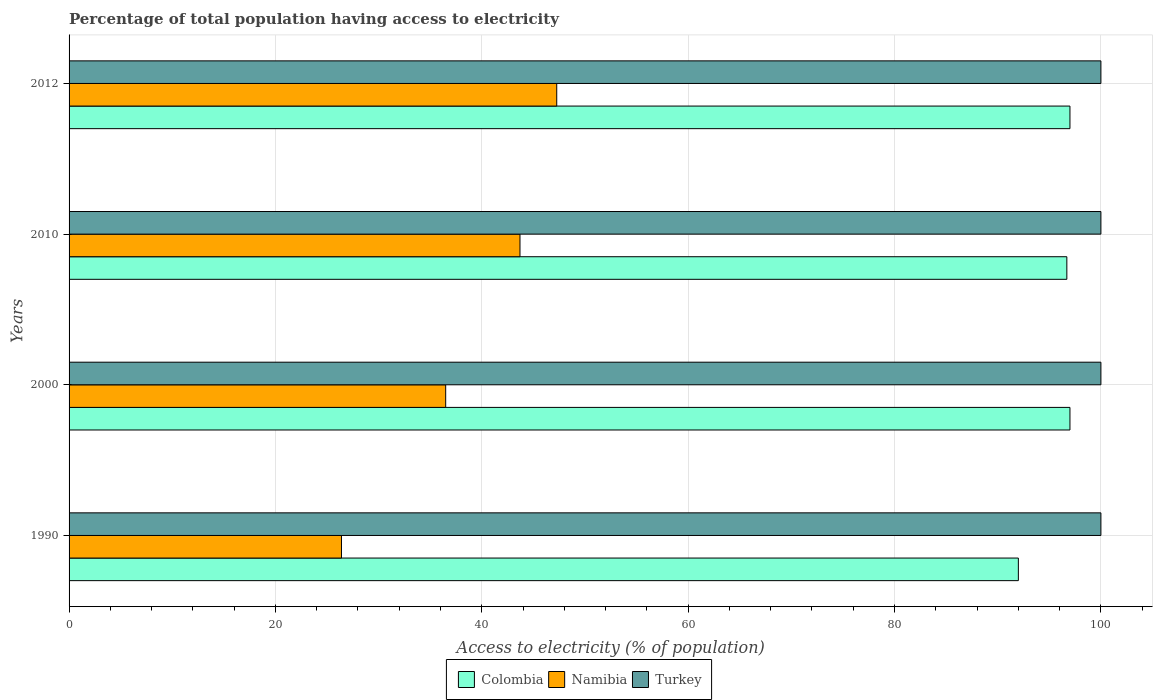How many groups of bars are there?
Keep it short and to the point. 4. Are the number of bars per tick equal to the number of legend labels?
Give a very brief answer. Yes. What is the percentage of population that have access to electricity in Colombia in 1990?
Give a very brief answer. 92. Across all years, what is the maximum percentage of population that have access to electricity in Namibia?
Provide a succinct answer. 47.26. Across all years, what is the minimum percentage of population that have access to electricity in Namibia?
Keep it short and to the point. 26.4. In which year was the percentage of population that have access to electricity in Colombia maximum?
Make the answer very short. 2000. What is the total percentage of population that have access to electricity in Namibia in the graph?
Ensure brevity in your answer.  153.86. What is the average percentage of population that have access to electricity in Namibia per year?
Ensure brevity in your answer.  38.47. What is the ratio of the percentage of population that have access to electricity in Colombia in 1990 to that in 2010?
Make the answer very short. 0.95. What is the difference between the highest and the second highest percentage of population that have access to electricity in Namibia?
Your answer should be compact. 3.56. Is the sum of the percentage of population that have access to electricity in Namibia in 1990 and 2010 greater than the maximum percentage of population that have access to electricity in Colombia across all years?
Your answer should be very brief. No. What does the 3rd bar from the top in 2000 represents?
Offer a very short reply. Colombia. What does the 1st bar from the bottom in 2000 represents?
Offer a very short reply. Colombia. Is it the case that in every year, the sum of the percentage of population that have access to electricity in Turkey and percentage of population that have access to electricity in Namibia is greater than the percentage of population that have access to electricity in Colombia?
Your response must be concise. Yes. How many bars are there?
Ensure brevity in your answer.  12. Are all the bars in the graph horizontal?
Make the answer very short. Yes. What is the difference between two consecutive major ticks on the X-axis?
Your response must be concise. 20. Are the values on the major ticks of X-axis written in scientific E-notation?
Your response must be concise. No. Does the graph contain any zero values?
Offer a very short reply. No. Does the graph contain grids?
Offer a very short reply. Yes. Where does the legend appear in the graph?
Provide a short and direct response. Bottom center. How are the legend labels stacked?
Keep it short and to the point. Horizontal. What is the title of the graph?
Your response must be concise. Percentage of total population having access to electricity. What is the label or title of the X-axis?
Offer a terse response. Access to electricity (% of population). What is the label or title of the Y-axis?
Offer a terse response. Years. What is the Access to electricity (% of population) of Colombia in 1990?
Offer a very short reply. 92. What is the Access to electricity (% of population) of Namibia in 1990?
Make the answer very short. 26.4. What is the Access to electricity (% of population) in Turkey in 1990?
Your answer should be very brief. 100. What is the Access to electricity (% of population) in Colombia in 2000?
Your response must be concise. 97. What is the Access to electricity (% of population) in Namibia in 2000?
Your answer should be very brief. 36.5. What is the Access to electricity (% of population) of Colombia in 2010?
Provide a short and direct response. 96.7. What is the Access to electricity (% of population) of Namibia in 2010?
Offer a terse response. 43.7. What is the Access to electricity (% of population) in Turkey in 2010?
Your answer should be compact. 100. What is the Access to electricity (% of population) in Colombia in 2012?
Your response must be concise. 97. What is the Access to electricity (% of population) in Namibia in 2012?
Keep it short and to the point. 47.26. Across all years, what is the maximum Access to electricity (% of population) of Colombia?
Offer a very short reply. 97. Across all years, what is the maximum Access to electricity (% of population) in Namibia?
Give a very brief answer. 47.26. Across all years, what is the minimum Access to electricity (% of population) in Colombia?
Give a very brief answer. 92. Across all years, what is the minimum Access to electricity (% of population) of Namibia?
Keep it short and to the point. 26.4. Across all years, what is the minimum Access to electricity (% of population) of Turkey?
Your response must be concise. 100. What is the total Access to electricity (% of population) of Colombia in the graph?
Keep it short and to the point. 382.7. What is the total Access to electricity (% of population) of Namibia in the graph?
Provide a succinct answer. 153.86. What is the total Access to electricity (% of population) in Turkey in the graph?
Provide a short and direct response. 400. What is the difference between the Access to electricity (% of population) in Colombia in 1990 and that in 2000?
Your answer should be compact. -5. What is the difference between the Access to electricity (% of population) in Namibia in 1990 and that in 2000?
Make the answer very short. -10.1. What is the difference between the Access to electricity (% of population) in Colombia in 1990 and that in 2010?
Give a very brief answer. -4.7. What is the difference between the Access to electricity (% of population) in Namibia in 1990 and that in 2010?
Your response must be concise. -17.3. What is the difference between the Access to electricity (% of population) in Namibia in 1990 and that in 2012?
Keep it short and to the point. -20.86. What is the difference between the Access to electricity (% of population) of Colombia in 2000 and that in 2010?
Offer a terse response. 0.3. What is the difference between the Access to electricity (% of population) of Namibia in 2000 and that in 2010?
Ensure brevity in your answer.  -7.2. What is the difference between the Access to electricity (% of population) in Turkey in 2000 and that in 2010?
Ensure brevity in your answer.  0. What is the difference between the Access to electricity (% of population) of Namibia in 2000 and that in 2012?
Give a very brief answer. -10.76. What is the difference between the Access to electricity (% of population) in Turkey in 2000 and that in 2012?
Provide a short and direct response. 0. What is the difference between the Access to electricity (% of population) in Colombia in 2010 and that in 2012?
Offer a very short reply. -0.3. What is the difference between the Access to electricity (% of population) in Namibia in 2010 and that in 2012?
Offer a terse response. -3.56. What is the difference between the Access to electricity (% of population) of Colombia in 1990 and the Access to electricity (% of population) of Namibia in 2000?
Your response must be concise. 55.5. What is the difference between the Access to electricity (% of population) in Colombia in 1990 and the Access to electricity (% of population) in Turkey in 2000?
Your answer should be compact. -8. What is the difference between the Access to electricity (% of population) of Namibia in 1990 and the Access to electricity (% of population) of Turkey in 2000?
Your answer should be very brief. -73.6. What is the difference between the Access to electricity (% of population) in Colombia in 1990 and the Access to electricity (% of population) in Namibia in 2010?
Your answer should be very brief. 48.3. What is the difference between the Access to electricity (% of population) of Colombia in 1990 and the Access to electricity (% of population) of Turkey in 2010?
Offer a very short reply. -8. What is the difference between the Access to electricity (% of population) in Namibia in 1990 and the Access to electricity (% of population) in Turkey in 2010?
Make the answer very short. -73.6. What is the difference between the Access to electricity (% of population) in Colombia in 1990 and the Access to electricity (% of population) in Namibia in 2012?
Ensure brevity in your answer.  44.74. What is the difference between the Access to electricity (% of population) in Colombia in 1990 and the Access to electricity (% of population) in Turkey in 2012?
Make the answer very short. -8. What is the difference between the Access to electricity (% of population) of Namibia in 1990 and the Access to electricity (% of population) of Turkey in 2012?
Offer a very short reply. -73.6. What is the difference between the Access to electricity (% of population) of Colombia in 2000 and the Access to electricity (% of population) of Namibia in 2010?
Make the answer very short. 53.3. What is the difference between the Access to electricity (% of population) of Colombia in 2000 and the Access to electricity (% of population) of Turkey in 2010?
Your response must be concise. -3. What is the difference between the Access to electricity (% of population) in Namibia in 2000 and the Access to electricity (% of population) in Turkey in 2010?
Offer a very short reply. -63.5. What is the difference between the Access to electricity (% of population) of Colombia in 2000 and the Access to electricity (% of population) of Namibia in 2012?
Your response must be concise. 49.74. What is the difference between the Access to electricity (% of population) of Namibia in 2000 and the Access to electricity (% of population) of Turkey in 2012?
Give a very brief answer. -63.5. What is the difference between the Access to electricity (% of population) in Colombia in 2010 and the Access to electricity (% of population) in Namibia in 2012?
Provide a succinct answer. 49.44. What is the difference between the Access to electricity (% of population) in Namibia in 2010 and the Access to electricity (% of population) in Turkey in 2012?
Provide a succinct answer. -56.3. What is the average Access to electricity (% of population) of Colombia per year?
Your response must be concise. 95.67. What is the average Access to electricity (% of population) in Namibia per year?
Ensure brevity in your answer.  38.47. What is the average Access to electricity (% of population) of Turkey per year?
Give a very brief answer. 100. In the year 1990, what is the difference between the Access to electricity (% of population) of Colombia and Access to electricity (% of population) of Namibia?
Make the answer very short. 65.6. In the year 1990, what is the difference between the Access to electricity (% of population) in Namibia and Access to electricity (% of population) in Turkey?
Your answer should be very brief. -73.6. In the year 2000, what is the difference between the Access to electricity (% of population) of Colombia and Access to electricity (% of population) of Namibia?
Keep it short and to the point. 60.5. In the year 2000, what is the difference between the Access to electricity (% of population) in Namibia and Access to electricity (% of population) in Turkey?
Provide a short and direct response. -63.5. In the year 2010, what is the difference between the Access to electricity (% of population) of Namibia and Access to electricity (% of population) of Turkey?
Offer a terse response. -56.3. In the year 2012, what is the difference between the Access to electricity (% of population) in Colombia and Access to electricity (% of population) in Namibia?
Offer a terse response. 49.74. In the year 2012, what is the difference between the Access to electricity (% of population) in Namibia and Access to electricity (% of population) in Turkey?
Offer a very short reply. -52.74. What is the ratio of the Access to electricity (% of population) in Colombia in 1990 to that in 2000?
Keep it short and to the point. 0.95. What is the ratio of the Access to electricity (% of population) of Namibia in 1990 to that in 2000?
Provide a short and direct response. 0.72. What is the ratio of the Access to electricity (% of population) in Colombia in 1990 to that in 2010?
Your answer should be very brief. 0.95. What is the ratio of the Access to electricity (% of population) in Namibia in 1990 to that in 2010?
Keep it short and to the point. 0.6. What is the ratio of the Access to electricity (% of population) in Turkey in 1990 to that in 2010?
Make the answer very short. 1. What is the ratio of the Access to electricity (% of population) of Colombia in 1990 to that in 2012?
Make the answer very short. 0.95. What is the ratio of the Access to electricity (% of population) in Namibia in 1990 to that in 2012?
Give a very brief answer. 0.56. What is the ratio of the Access to electricity (% of population) of Namibia in 2000 to that in 2010?
Provide a succinct answer. 0.84. What is the ratio of the Access to electricity (% of population) in Colombia in 2000 to that in 2012?
Give a very brief answer. 1. What is the ratio of the Access to electricity (% of population) in Namibia in 2000 to that in 2012?
Give a very brief answer. 0.77. What is the ratio of the Access to electricity (% of population) of Namibia in 2010 to that in 2012?
Offer a terse response. 0.92. What is the ratio of the Access to electricity (% of population) in Turkey in 2010 to that in 2012?
Offer a terse response. 1. What is the difference between the highest and the second highest Access to electricity (% of population) of Colombia?
Make the answer very short. 0. What is the difference between the highest and the second highest Access to electricity (% of population) of Namibia?
Your answer should be very brief. 3.56. What is the difference between the highest and the lowest Access to electricity (% of population) in Namibia?
Keep it short and to the point. 20.86. 